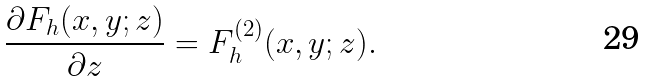Convert formula to latex. <formula><loc_0><loc_0><loc_500><loc_500>\frac { \partial F _ { h } ( x , y ; z ) } { \partial z } = F ^ { ( 2 ) } _ { h } ( x , y ; z ) .</formula> 